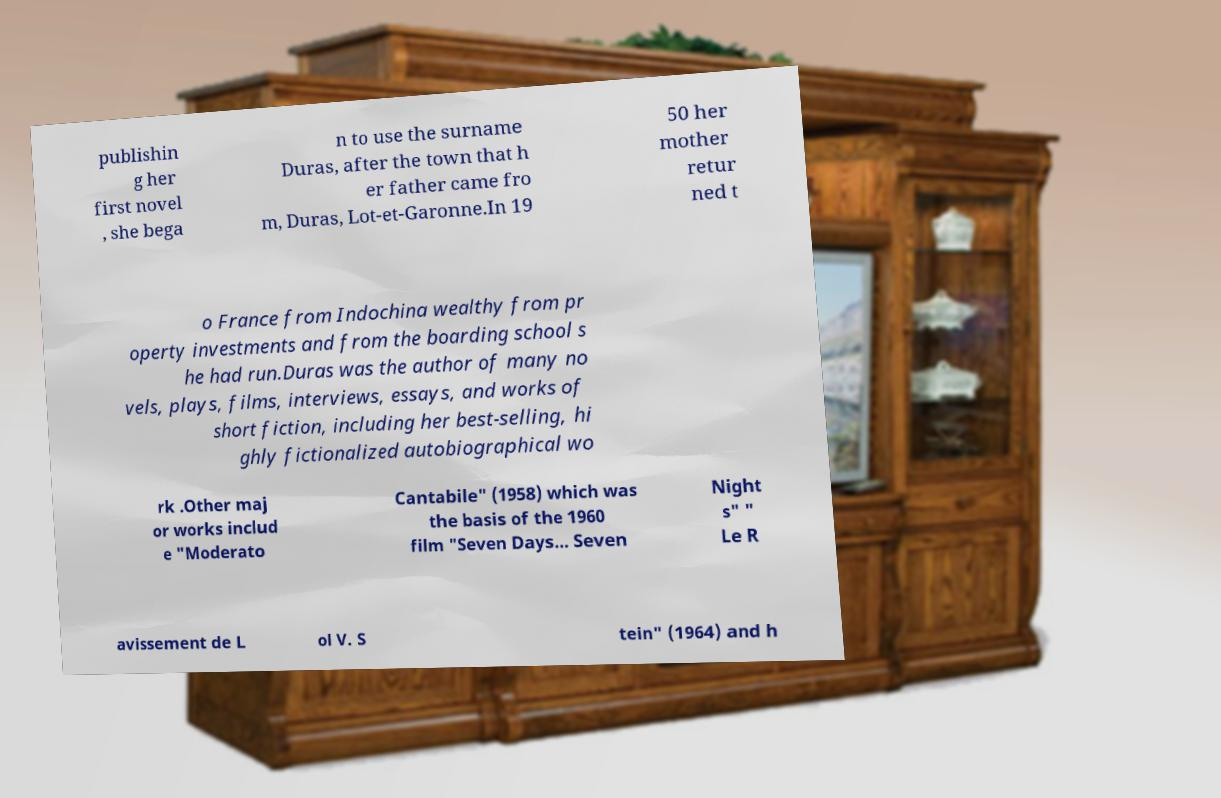Could you assist in decoding the text presented in this image and type it out clearly? publishin g her first novel , she bega n to use the surname Duras, after the town that h er father came fro m, Duras, Lot-et-Garonne.In 19 50 her mother retur ned t o France from Indochina wealthy from pr operty investments and from the boarding school s he had run.Duras was the author of many no vels, plays, films, interviews, essays, and works of short fiction, including her best-selling, hi ghly fictionalized autobiographical wo rk .Other maj or works includ e "Moderato Cantabile" (1958) which was the basis of the 1960 film "Seven Days... Seven Night s" " Le R avissement de L ol V. S tein" (1964) and h 